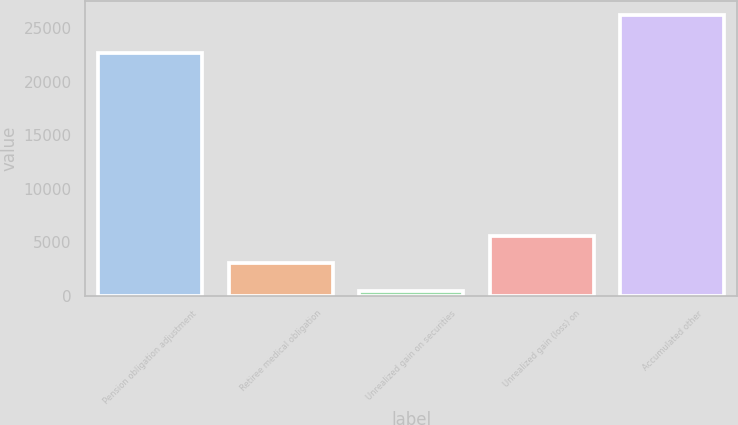Convert chart. <chart><loc_0><loc_0><loc_500><loc_500><bar_chart><fcel>Pension obligation adjustment<fcel>Retiree medical obligation<fcel>Unrealized gain on securities<fcel>Unrealized gain (loss) on<fcel>Accumulated other<nl><fcel>22672<fcel>3030.5<fcel>451<fcel>5610<fcel>26246<nl></chart> 